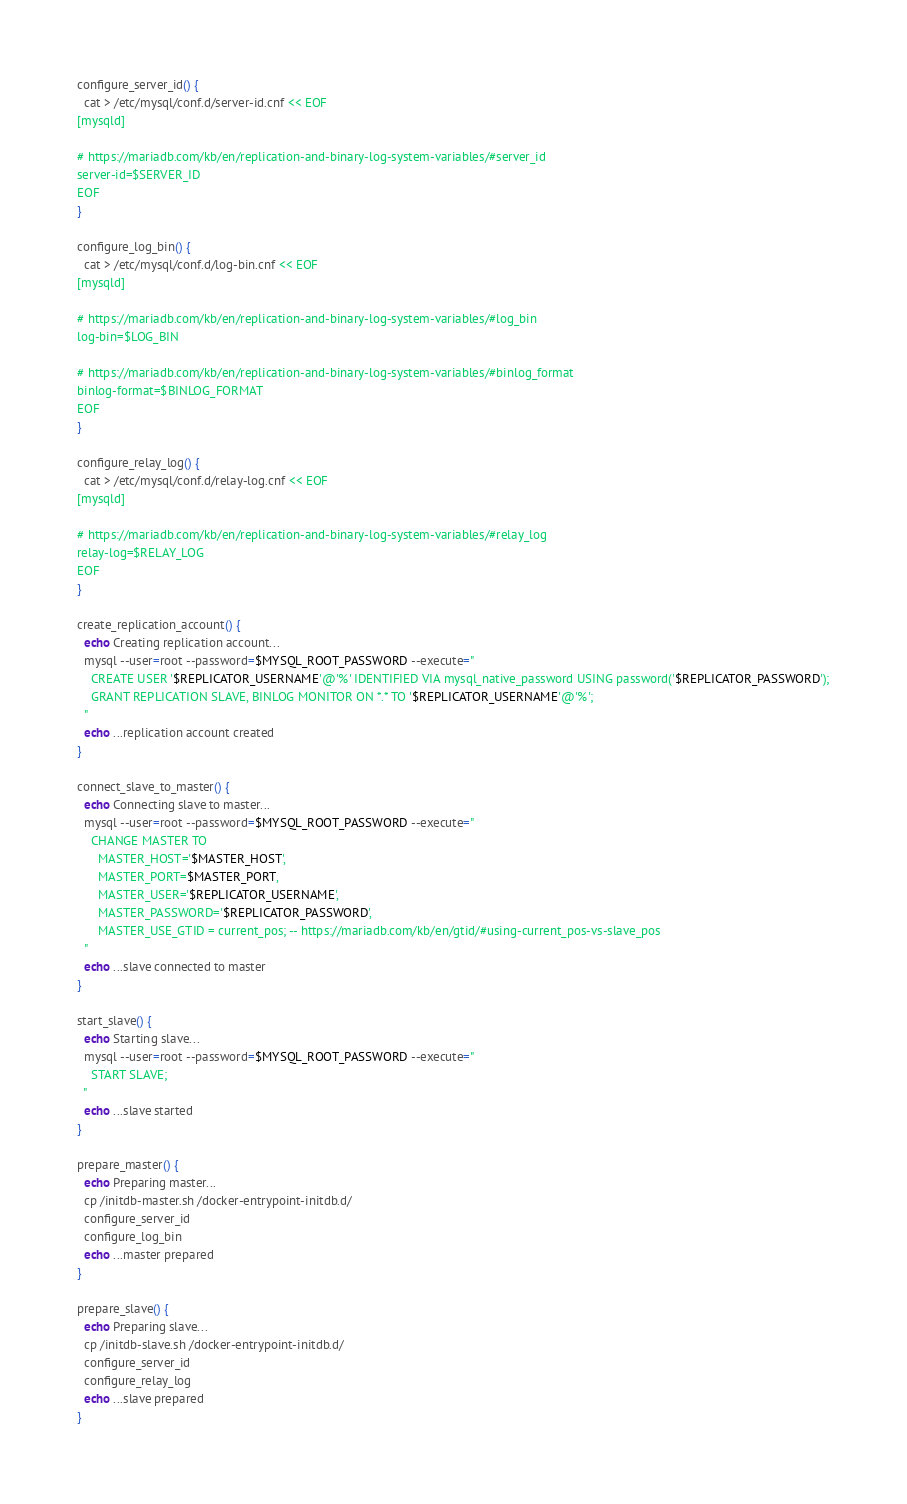Convert code to text. <code><loc_0><loc_0><loc_500><loc_500><_Bash_>configure_server_id() {
  cat > /etc/mysql/conf.d/server-id.cnf << EOF
[mysqld]

# https://mariadb.com/kb/en/replication-and-binary-log-system-variables/#server_id
server-id=$SERVER_ID
EOF
}

configure_log_bin() {
  cat > /etc/mysql/conf.d/log-bin.cnf << EOF
[mysqld]

# https://mariadb.com/kb/en/replication-and-binary-log-system-variables/#log_bin
log-bin=$LOG_BIN

# https://mariadb.com/kb/en/replication-and-binary-log-system-variables/#binlog_format
binlog-format=$BINLOG_FORMAT
EOF
}

configure_relay_log() {
  cat > /etc/mysql/conf.d/relay-log.cnf << EOF
[mysqld]

# https://mariadb.com/kb/en/replication-and-binary-log-system-variables/#relay_log
relay-log=$RELAY_LOG
EOF
}

create_replication_account() {
  echo Creating replication account...
  mysql --user=root --password=$MYSQL_ROOT_PASSWORD --execute="
    CREATE USER '$REPLICATOR_USERNAME'@'%' IDENTIFIED VIA mysql_native_password USING password('$REPLICATOR_PASSWORD');
    GRANT REPLICATION SLAVE, BINLOG MONITOR ON *.* TO '$REPLICATOR_USERNAME'@'%';
  "
  echo ...replication account created
}

connect_slave_to_master() {
  echo Connecting slave to master...
  mysql --user=root --password=$MYSQL_ROOT_PASSWORD --execute="
    CHANGE MASTER TO
      MASTER_HOST='$MASTER_HOST',
      MASTER_PORT=$MASTER_PORT,
      MASTER_USER='$REPLICATOR_USERNAME',
      MASTER_PASSWORD='$REPLICATOR_PASSWORD',
      MASTER_USE_GTID = current_pos; -- https://mariadb.com/kb/en/gtid/#using-current_pos-vs-slave_pos
  "
  echo ...slave connected to master
}

start_slave() {
  echo Starting slave...
  mysql --user=root --password=$MYSQL_ROOT_PASSWORD --execute="
    START SLAVE;
  "
  echo ...slave started
}

prepare_master() {
  echo Preparing master...
  cp /initdb-master.sh /docker-entrypoint-initdb.d/
  configure_server_id
  configure_log_bin
  echo ...master prepared
}

prepare_slave() {
  echo Preparing slave...
  cp /initdb-slave.sh /docker-entrypoint-initdb.d/
  configure_server_id
  configure_relay_log
  echo ...slave prepared
}
</code> 